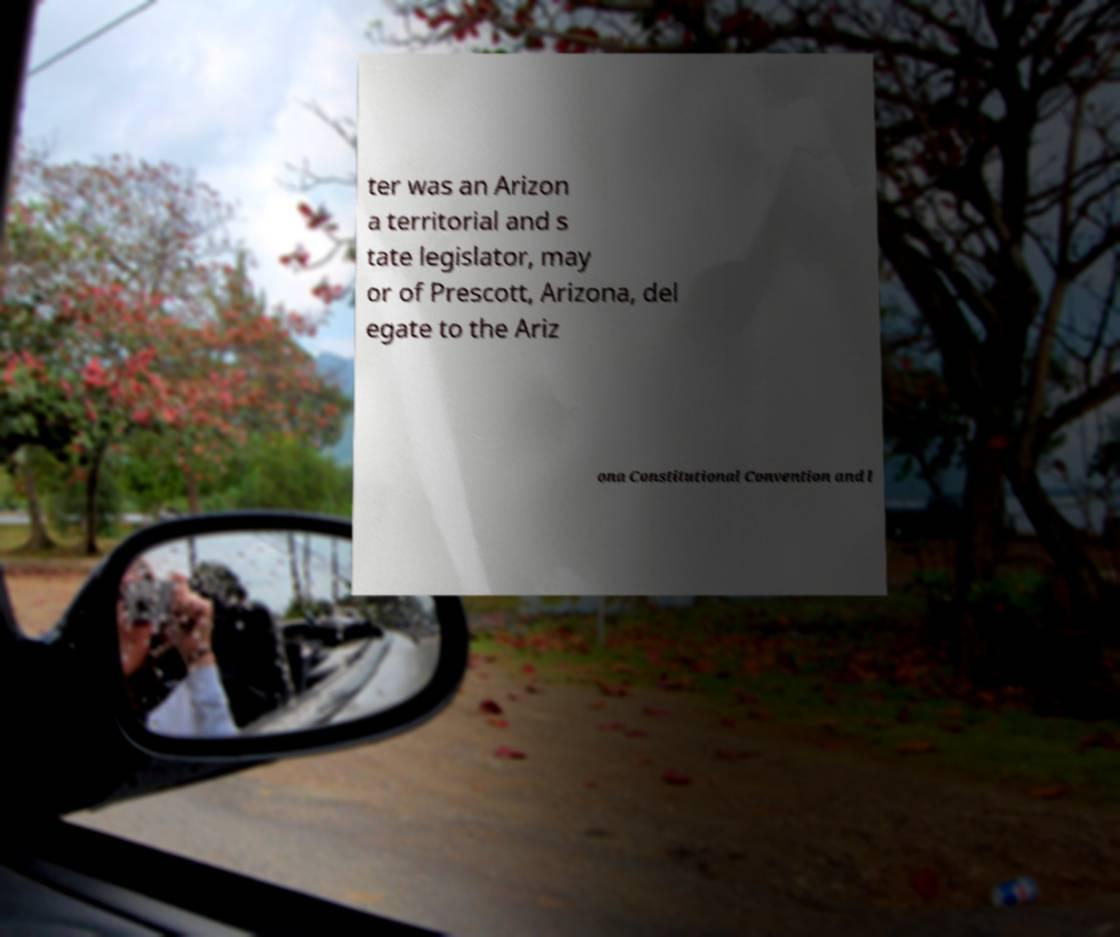Please identify and transcribe the text found in this image. ter was an Arizon a territorial and s tate legislator, may or of Prescott, Arizona, del egate to the Ariz ona Constitutional Convention and l 